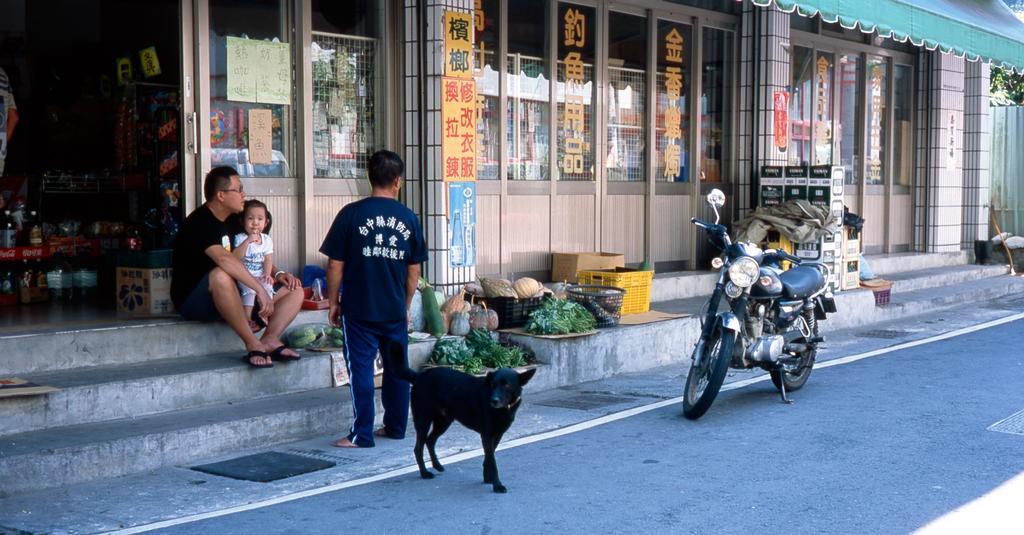In one or two sentences, can you explain what this image depicts? As we can see in the image there are three people, black color dog, vegetables, door, motor cycle, baskets and buildings. On the left side there are stairs. 